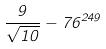<formula> <loc_0><loc_0><loc_500><loc_500>\frac { 9 } { \sqrt { 1 0 } } - 7 6 ^ { 2 4 9 }</formula> 